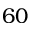Convert formula to latex. <formula><loc_0><loc_0><loc_500><loc_500>6 0</formula> 